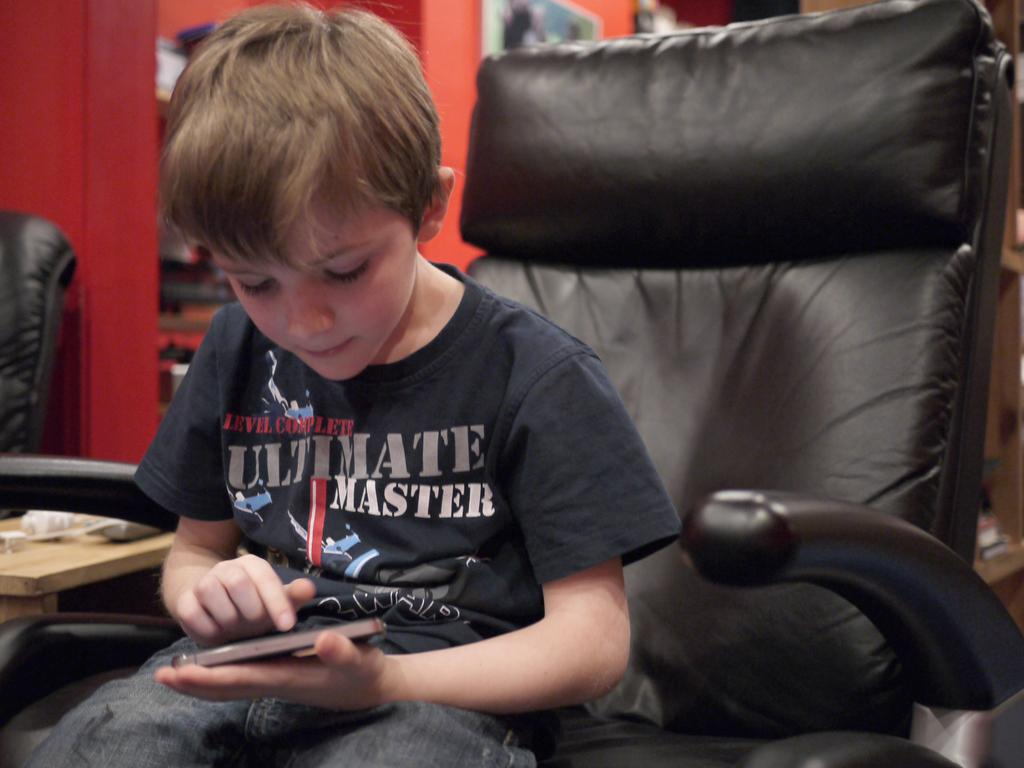Who is the main subject in the image? There is a boy in the image. What is the boy doing in the image? The boy is playing with a mobile. Where is the boy sitting while playing with the mobile? The boy is sitting in a chair. What can be seen in the background of the image? There is a wall in the background of the image. What type of thread is being used to fly the plane in the image? There is no plane present in the image, and therefore no thread being used to fly it. 